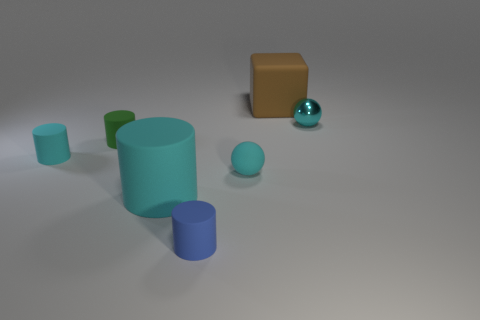Add 2 large rubber cylinders. How many objects exist? 9 Subtract all cubes. How many objects are left? 6 Add 3 cyan cylinders. How many cyan cylinders are left? 5 Add 4 tiny green blocks. How many tiny green blocks exist? 4 Subtract 0 red cylinders. How many objects are left? 7 Subtract all brown matte spheres. Subtract all brown objects. How many objects are left? 6 